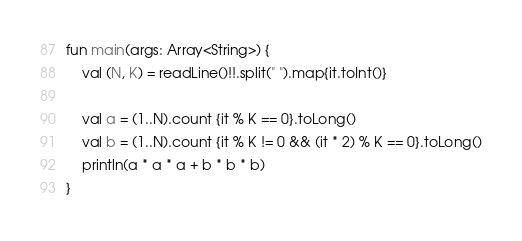<code> <loc_0><loc_0><loc_500><loc_500><_Kotlin_>fun main(args: Array<String>) {
    val (N, K) = readLine()!!.split(" ").map{it.toInt()}

    val a = (1..N).count {it % K == 0}.toLong()
    val b = (1..N).count {it % K != 0 && (it * 2) % K == 0}.toLong()
    println(a * a * a + b * b * b)
}
</code> 